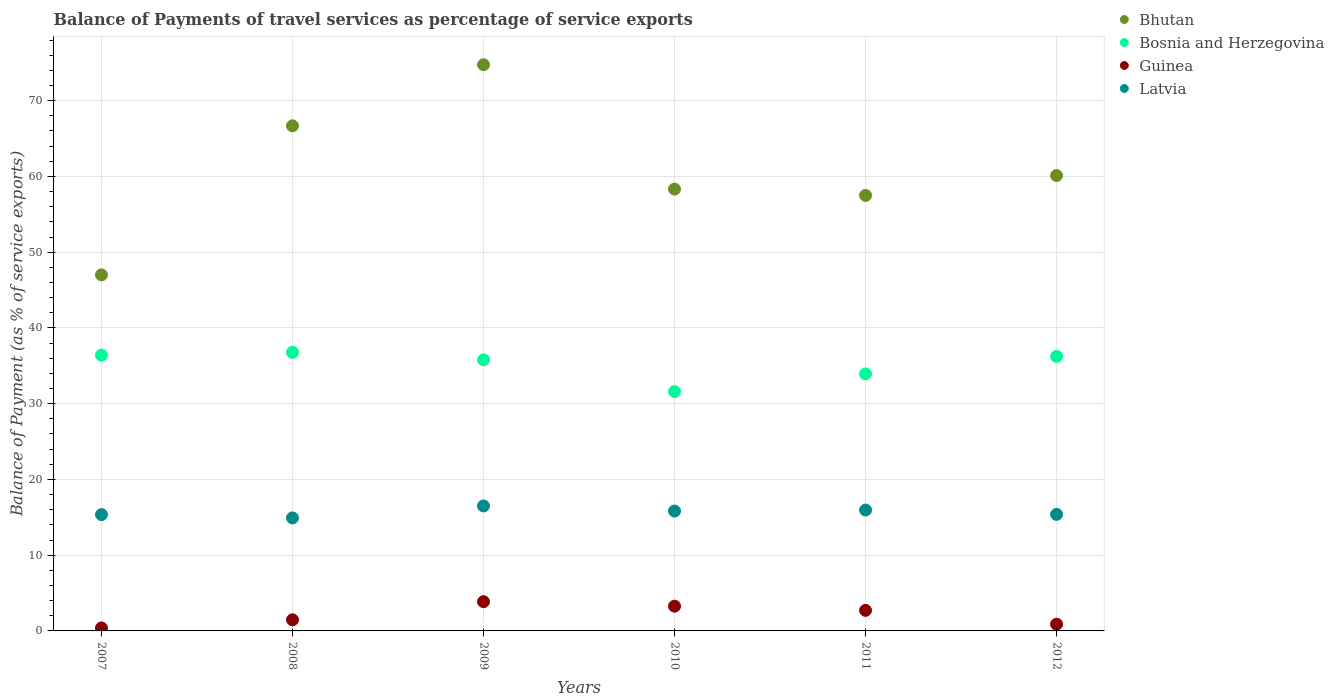What is the balance of payments of travel services in Bosnia and Herzegovina in 2009?
Ensure brevity in your answer.  35.79. Across all years, what is the maximum balance of payments of travel services in Bhutan?
Offer a very short reply. 74.75. Across all years, what is the minimum balance of payments of travel services in Latvia?
Give a very brief answer. 14.92. In which year was the balance of payments of travel services in Guinea minimum?
Your answer should be compact. 2007. What is the total balance of payments of travel services in Bhutan in the graph?
Keep it short and to the point. 364.38. What is the difference between the balance of payments of travel services in Latvia in 2007 and that in 2012?
Ensure brevity in your answer.  -0.04. What is the difference between the balance of payments of travel services in Bhutan in 2011 and the balance of payments of travel services in Guinea in 2012?
Offer a very short reply. 56.61. What is the average balance of payments of travel services in Latvia per year?
Provide a succinct answer. 15.66. In the year 2012, what is the difference between the balance of payments of travel services in Guinea and balance of payments of travel services in Latvia?
Provide a short and direct response. -14.5. In how many years, is the balance of payments of travel services in Bhutan greater than 16 %?
Your response must be concise. 6. What is the ratio of the balance of payments of travel services in Bosnia and Herzegovina in 2007 to that in 2008?
Your response must be concise. 0.99. Is the balance of payments of travel services in Guinea in 2008 less than that in 2011?
Offer a very short reply. Yes. What is the difference between the highest and the second highest balance of payments of travel services in Bhutan?
Your response must be concise. 8.06. What is the difference between the highest and the lowest balance of payments of travel services in Guinea?
Offer a terse response. 3.47. In how many years, is the balance of payments of travel services in Bosnia and Herzegovina greater than the average balance of payments of travel services in Bosnia and Herzegovina taken over all years?
Your answer should be very brief. 4. Is the sum of the balance of payments of travel services in Bhutan in 2007 and 2009 greater than the maximum balance of payments of travel services in Guinea across all years?
Keep it short and to the point. Yes. Is it the case that in every year, the sum of the balance of payments of travel services in Guinea and balance of payments of travel services in Bosnia and Herzegovina  is greater than the sum of balance of payments of travel services in Bhutan and balance of payments of travel services in Latvia?
Make the answer very short. Yes. Does the balance of payments of travel services in Latvia monotonically increase over the years?
Keep it short and to the point. No. Is the balance of payments of travel services in Bosnia and Herzegovina strictly greater than the balance of payments of travel services in Latvia over the years?
Provide a short and direct response. Yes. Is the balance of payments of travel services in Bosnia and Herzegovina strictly less than the balance of payments of travel services in Bhutan over the years?
Offer a terse response. Yes. How many dotlines are there?
Make the answer very short. 4. How many years are there in the graph?
Your answer should be very brief. 6. Does the graph contain grids?
Offer a very short reply. Yes. How many legend labels are there?
Offer a very short reply. 4. What is the title of the graph?
Provide a succinct answer. Balance of Payments of travel services as percentage of service exports. Does "Ukraine" appear as one of the legend labels in the graph?
Offer a very short reply. No. What is the label or title of the Y-axis?
Ensure brevity in your answer.  Balance of Payment (as % of service exports). What is the Balance of Payment (as % of service exports) of Bhutan in 2007?
Ensure brevity in your answer.  47. What is the Balance of Payment (as % of service exports) of Bosnia and Herzegovina in 2007?
Your answer should be very brief. 36.41. What is the Balance of Payment (as % of service exports) in Guinea in 2007?
Your response must be concise. 0.39. What is the Balance of Payment (as % of service exports) in Latvia in 2007?
Offer a terse response. 15.35. What is the Balance of Payment (as % of service exports) of Bhutan in 2008?
Provide a short and direct response. 66.68. What is the Balance of Payment (as % of service exports) of Bosnia and Herzegovina in 2008?
Give a very brief answer. 36.78. What is the Balance of Payment (as % of service exports) in Guinea in 2008?
Provide a short and direct response. 1.47. What is the Balance of Payment (as % of service exports) of Latvia in 2008?
Keep it short and to the point. 14.92. What is the Balance of Payment (as % of service exports) of Bhutan in 2009?
Offer a very short reply. 74.75. What is the Balance of Payment (as % of service exports) of Bosnia and Herzegovina in 2009?
Your response must be concise. 35.79. What is the Balance of Payment (as % of service exports) of Guinea in 2009?
Offer a very short reply. 3.86. What is the Balance of Payment (as % of service exports) in Latvia in 2009?
Ensure brevity in your answer.  16.5. What is the Balance of Payment (as % of service exports) in Bhutan in 2010?
Keep it short and to the point. 58.33. What is the Balance of Payment (as % of service exports) of Bosnia and Herzegovina in 2010?
Your answer should be very brief. 31.59. What is the Balance of Payment (as % of service exports) in Guinea in 2010?
Your response must be concise. 3.27. What is the Balance of Payment (as % of service exports) of Latvia in 2010?
Offer a terse response. 15.83. What is the Balance of Payment (as % of service exports) in Bhutan in 2011?
Give a very brief answer. 57.5. What is the Balance of Payment (as % of service exports) in Bosnia and Herzegovina in 2011?
Make the answer very short. 33.93. What is the Balance of Payment (as % of service exports) in Guinea in 2011?
Ensure brevity in your answer.  2.71. What is the Balance of Payment (as % of service exports) in Latvia in 2011?
Keep it short and to the point. 15.96. What is the Balance of Payment (as % of service exports) of Bhutan in 2012?
Your response must be concise. 60.12. What is the Balance of Payment (as % of service exports) in Bosnia and Herzegovina in 2012?
Provide a short and direct response. 36.25. What is the Balance of Payment (as % of service exports) in Guinea in 2012?
Give a very brief answer. 0.89. What is the Balance of Payment (as % of service exports) in Latvia in 2012?
Offer a very short reply. 15.39. Across all years, what is the maximum Balance of Payment (as % of service exports) in Bhutan?
Keep it short and to the point. 74.75. Across all years, what is the maximum Balance of Payment (as % of service exports) in Bosnia and Herzegovina?
Keep it short and to the point. 36.78. Across all years, what is the maximum Balance of Payment (as % of service exports) in Guinea?
Provide a short and direct response. 3.86. Across all years, what is the maximum Balance of Payment (as % of service exports) of Latvia?
Provide a short and direct response. 16.5. Across all years, what is the minimum Balance of Payment (as % of service exports) in Bhutan?
Give a very brief answer. 47. Across all years, what is the minimum Balance of Payment (as % of service exports) in Bosnia and Herzegovina?
Your response must be concise. 31.59. Across all years, what is the minimum Balance of Payment (as % of service exports) of Guinea?
Provide a succinct answer. 0.39. Across all years, what is the minimum Balance of Payment (as % of service exports) of Latvia?
Ensure brevity in your answer.  14.92. What is the total Balance of Payment (as % of service exports) of Bhutan in the graph?
Offer a very short reply. 364.38. What is the total Balance of Payment (as % of service exports) of Bosnia and Herzegovina in the graph?
Your answer should be compact. 210.75. What is the total Balance of Payment (as % of service exports) in Guinea in the graph?
Make the answer very short. 12.59. What is the total Balance of Payment (as % of service exports) in Latvia in the graph?
Provide a succinct answer. 93.94. What is the difference between the Balance of Payment (as % of service exports) in Bhutan in 2007 and that in 2008?
Provide a short and direct response. -19.68. What is the difference between the Balance of Payment (as % of service exports) in Bosnia and Herzegovina in 2007 and that in 2008?
Keep it short and to the point. -0.38. What is the difference between the Balance of Payment (as % of service exports) of Guinea in 2007 and that in 2008?
Ensure brevity in your answer.  -1.08. What is the difference between the Balance of Payment (as % of service exports) of Latvia in 2007 and that in 2008?
Ensure brevity in your answer.  0.43. What is the difference between the Balance of Payment (as % of service exports) of Bhutan in 2007 and that in 2009?
Provide a succinct answer. -27.74. What is the difference between the Balance of Payment (as % of service exports) of Bosnia and Herzegovina in 2007 and that in 2009?
Offer a terse response. 0.62. What is the difference between the Balance of Payment (as % of service exports) of Guinea in 2007 and that in 2009?
Give a very brief answer. -3.47. What is the difference between the Balance of Payment (as % of service exports) of Latvia in 2007 and that in 2009?
Make the answer very short. -1.15. What is the difference between the Balance of Payment (as % of service exports) in Bhutan in 2007 and that in 2010?
Keep it short and to the point. -11.33. What is the difference between the Balance of Payment (as % of service exports) in Bosnia and Herzegovina in 2007 and that in 2010?
Ensure brevity in your answer.  4.81. What is the difference between the Balance of Payment (as % of service exports) of Guinea in 2007 and that in 2010?
Keep it short and to the point. -2.88. What is the difference between the Balance of Payment (as % of service exports) in Latvia in 2007 and that in 2010?
Keep it short and to the point. -0.48. What is the difference between the Balance of Payment (as % of service exports) in Bhutan in 2007 and that in 2011?
Provide a short and direct response. -10.49. What is the difference between the Balance of Payment (as % of service exports) of Bosnia and Herzegovina in 2007 and that in 2011?
Provide a succinct answer. 2.47. What is the difference between the Balance of Payment (as % of service exports) of Guinea in 2007 and that in 2011?
Offer a very short reply. -2.32. What is the difference between the Balance of Payment (as % of service exports) in Latvia in 2007 and that in 2011?
Provide a short and direct response. -0.61. What is the difference between the Balance of Payment (as % of service exports) of Bhutan in 2007 and that in 2012?
Provide a succinct answer. -13.12. What is the difference between the Balance of Payment (as % of service exports) in Bosnia and Herzegovina in 2007 and that in 2012?
Offer a very short reply. 0.16. What is the difference between the Balance of Payment (as % of service exports) in Guinea in 2007 and that in 2012?
Your answer should be very brief. -0.5. What is the difference between the Balance of Payment (as % of service exports) in Latvia in 2007 and that in 2012?
Offer a terse response. -0.04. What is the difference between the Balance of Payment (as % of service exports) in Bhutan in 2008 and that in 2009?
Make the answer very short. -8.06. What is the difference between the Balance of Payment (as % of service exports) of Guinea in 2008 and that in 2009?
Provide a succinct answer. -2.39. What is the difference between the Balance of Payment (as % of service exports) of Latvia in 2008 and that in 2009?
Ensure brevity in your answer.  -1.58. What is the difference between the Balance of Payment (as % of service exports) of Bhutan in 2008 and that in 2010?
Provide a short and direct response. 8.36. What is the difference between the Balance of Payment (as % of service exports) in Bosnia and Herzegovina in 2008 and that in 2010?
Provide a succinct answer. 5.19. What is the difference between the Balance of Payment (as % of service exports) in Guinea in 2008 and that in 2010?
Offer a very short reply. -1.8. What is the difference between the Balance of Payment (as % of service exports) in Latvia in 2008 and that in 2010?
Offer a terse response. -0.91. What is the difference between the Balance of Payment (as % of service exports) of Bhutan in 2008 and that in 2011?
Your answer should be compact. 9.19. What is the difference between the Balance of Payment (as % of service exports) of Bosnia and Herzegovina in 2008 and that in 2011?
Your response must be concise. 2.85. What is the difference between the Balance of Payment (as % of service exports) in Guinea in 2008 and that in 2011?
Give a very brief answer. -1.25. What is the difference between the Balance of Payment (as % of service exports) of Latvia in 2008 and that in 2011?
Keep it short and to the point. -1.04. What is the difference between the Balance of Payment (as % of service exports) of Bhutan in 2008 and that in 2012?
Provide a succinct answer. 6.56. What is the difference between the Balance of Payment (as % of service exports) in Bosnia and Herzegovina in 2008 and that in 2012?
Make the answer very short. 0.54. What is the difference between the Balance of Payment (as % of service exports) of Guinea in 2008 and that in 2012?
Your answer should be compact. 0.58. What is the difference between the Balance of Payment (as % of service exports) in Latvia in 2008 and that in 2012?
Your answer should be compact. -0.47. What is the difference between the Balance of Payment (as % of service exports) of Bhutan in 2009 and that in 2010?
Ensure brevity in your answer.  16.42. What is the difference between the Balance of Payment (as % of service exports) in Bosnia and Herzegovina in 2009 and that in 2010?
Give a very brief answer. 4.2. What is the difference between the Balance of Payment (as % of service exports) in Guinea in 2009 and that in 2010?
Make the answer very short. 0.59. What is the difference between the Balance of Payment (as % of service exports) of Latvia in 2009 and that in 2010?
Offer a very short reply. 0.67. What is the difference between the Balance of Payment (as % of service exports) of Bhutan in 2009 and that in 2011?
Your answer should be compact. 17.25. What is the difference between the Balance of Payment (as % of service exports) in Bosnia and Herzegovina in 2009 and that in 2011?
Keep it short and to the point. 1.86. What is the difference between the Balance of Payment (as % of service exports) of Guinea in 2009 and that in 2011?
Ensure brevity in your answer.  1.15. What is the difference between the Balance of Payment (as % of service exports) of Latvia in 2009 and that in 2011?
Keep it short and to the point. 0.54. What is the difference between the Balance of Payment (as % of service exports) of Bhutan in 2009 and that in 2012?
Your response must be concise. 14.63. What is the difference between the Balance of Payment (as % of service exports) of Bosnia and Herzegovina in 2009 and that in 2012?
Your response must be concise. -0.46. What is the difference between the Balance of Payment (as % of service exports) of Guinea in 2009 and that in 2012?
Keep it short and to the point. 2.98. What is the difference between the Balance of Payment (as % of service exports) of Latvia in 2009 and that in 2012?
Ensure brevity in your answer.  1.11. What is the difference between the Balance of Payment (as % of service exports) of Bhutan in 2010 and that in 2011?
Offer a very short reply. 0.83. What is the difference between the Balance of Payment (as % of service exports) in Bosnia and Herzegovina in 2010 and that in 2011?
Offer a terse response. -2.34. What is the difference between the Balance of Payment (as % of service exports) in Guinea in 2010 and that in 2011?
Provide a short and direct response. 0.55. What is the difference between the Balance of Payment (as % of service exports) of Latvia in 2010 and that in 2011?
Keep it short and to the point. -0.13. What is the difference between the Balance of Payment (as % of service exports) in Bhutan in 2010 and that in 2012?
Your answer should be compact. -1.79. What is the difference between the Balance of Payment (as % of service exports) of Bosnia and Herzegovina in 2010 and that in 2012?
Your response must be concise. -4.66. What is the difference between the Balance of Payment (as % of service exports) of Guinea in 2010 and that in 2012?
Provide a short and direct response. 2.38. What is the difference between the Balance of Payment (as % of service exports) in Latvia in 2010 and that in 2012?
Keep it short and to the point. 0.44. What is the difference between the Balance of Payment (as % of service exports) of Bhutan in 2011 and that in 2012?
Give a very brief answer. -2.62. What is the difference between the Balance of Payment (as % of service exports) in Bosnia and Herzegovina in 2011 and that in 2012?
Provide a short and direct response. -2.32. What is the difference between the Balance of Payment (as % of service exports) in Guinea in 2011 and that in 2012?
Ensure brevity in your answer.  1.83. What is the difference between the Balance of Payment (as % of service exports) in Latvia in 2011 and that in 2012?
Make the answer very short. 0.57. What is the difference between the Balance of Payment (as % of service exports) in Bhutan in 2007 and the Balance of Payment (as % of service exports) in Bosnia and Herzegovina in 2008?
Make the answer very short. 10.22. What is the difference between the Balance of Payment (as % of service exports) in Bhutan in 2007 and the Balance of Payment (as % of service exports) in Guinea in 2008?
Your answer should be very brief. 45.53. What is the difference between the Balance of Payment (as % of service exports) of Bhutan in 2007 and the Balance of Payment (as % of service exports) of Latvia in 2008?
Keep it short and to the point. 32.08. What is the difference between the Balance of Payment (as % of service exports) of Bosnia and Herzegovina in 2007 and the Balance of Payment (as % of service exports) of Guinea in 2008?
Make the answer very short. 34.94. What is the difference between the Balance of Payment (as % of service exports) of Bosnia and Herzegovina in 2007 and the Balance of Payment (as % of service exports) of Latvia in 2008?
Make the answer very short. 21.48. What is the difference between the Balance of Payment (as % of service exports) in Guinea in 2007 and the Balance of Payment (as % of service exports) in Latvia in 2008?
Ensure brevity in your answer.  -14.53. What is the difference between the Balance of Payment (as % of service exports) of Bhutan in 2007 and the Balance of Payment (as % of service exports) of Bosnia and Herzegovina in 2009?
Make the answer very short. 11.21. What is the difference between the Balance of Payment (as % of service exports) in Bhutan in 2007 and the Balance of Payment (as % of service exports) in Guinea in 2009?
Your response must be concise. 43.14. What is the difference between the Balance of Payment (as % of service exports) in Bhutan in 2007 and the Balance of Payment (as % of service exports) in Latvia in 2009?
Your answer should be very brief. 30.5. What is the difference between the Balance of Payment (as % of service exports) of Bosnia and Herzegovina in 2007 and the Balance of Payment (as % of service exports) of Guinea in 2009?
Provide a succinct answer. 32.54. What is the difference between the Balance of Payment (as % of service exports) of Bosnia and Herzegovina in 2007 and the Balance of Payment (as % of service exports) of Latvia in 2009?
Keep it short and to the point. 19.91. What is the difference between the Balance of Payment (as % of service exports) of Guinea in 2007 and the Balance of Payment (as % of service exports) of Latvia in 2009?
Provide a succinct answer. -16.11. What is the difference between the Balance of Payment (as % of service exports) of Bhutan in 2007 and the Balance of Payment (as % of service exports) of Bosnia and Herzegovina in 2010?
Your response must be concise. 15.41. What is the difference between the Balance of Payment (as % of service exports) in Bhutan in 2007 and the Balance of Payment (as % of service exports) in Guinea in 2010?
Your answer should be compact. 43.73. What is the difference between the Balance of Payment (as % of service exports) of Bhutan in 2007 and the Balance of Payment (as % of service exports) of Latvia in 2010?
Your answer should be compact. 31.17. What is the difference between the Balance of Payment (as % of service exports) of Bosnia and Herzegovina in 2007 and the Balance of Payment (as % of service exports) of Guinea in 2010?
Provide a succinct answer. 33.14. What is the difference between the Balance of Payment (as % of service exports) in Bosnia and Herzegovina in 2007 and the Balance of Payment (as % of service exports) in Latvia in 2010?
Make the answer very short. 20.58. What is the difference between the Balance of Payment (as % of service exports) of Guinea in 2007 and the Balance of Payment (as % of service exports) of Latvia in 2010?
Your response must be concise. -15.44. What is the difference between the Balance of Payment (as % of service exports) in Bhutan in 2007 and the Balance of Payment (as % of service exports) in Bosnia and Herzegovina in 2011?
Provide a short and direct response. 13.07. What is the difference between the Balance of Payment (as % of service exports) in Bhutan in 2007 and the Balance of Payment (as % of service exports) in Guinea in 2011?
Provide a succinct answer. 44.29. What is the difference between the Balance of Payment (as % of service exports) of Bhutan in 2007 and the Balance of Payment (as % of service exports) of Latvia in 2011?
Your response must be concise. 31.04. What is the difference between the Balance of Payment (as % of service exports) of Bosnia and Herzegovina in 2007 and the Balance of Payment (as % of service exports) of Guinea in 2011?
Your response must be concise. 33.69. What is the difference between the Balance of Payment (as % of service exports) of Bosnia and Herzegovina in 2007 and the Balance of Payment (as % of service exports) of Latvia in 2011?
Ensure brevity in your answer.  20.45. What is the difference between the Balance of Payment (as % of service exports) of Guinea in 2007 and the Balance of Payment (as % of service exports) of Latvia in 2011?
Provide a short and direct response. -15.57. What is the difference between the Balance of Payment (as % of service exports) in Bhutan in 2007 and the Balance of Payment (as % of service exports) in Bosnia and Herzegovina in 2012?
Provide a short and direct response. 10.75. What is the difference between the Balance of Payment (as % of service exports) of Bhutan in 2007 and the Balance of Payment (as % of service exports) of Guinea in 2012?
Offer a terse response. 46.12. What is the difference between the Balance of Payment (as % of service exports) in Bhutan in 2007 and the Balance of Payment (as % of service exports) in Latvia in 2012?
Offer a very short reply. 31.61. What is the difference between the Balance of Payment (as % of service exports) of Bosnia and Herzegovina in 2007 and the Balance of Payment (as % of service exports) of Guinea in 2012?
Offer a very short reply. 35.52. What is the difference between the Balance of Payment (as % of service exports) in Bosnia and Herzegovina in 2007 and the Balance of Payment (as % of service exports) in Latvia in 2012?
Give a very brief answer. 21.02. What is the difference between the Balance of Payment (as % of service exports) in Guinea in 2007 and the Balance of Payment (as % of service exports) in Latvia in 2012?
Make the answer very short. -15. What is the difference between the Balance of Payment (as % of service exports) of Bhutan in 2008 and the Balance of Payment (as % of service exports) of Bosnia and Herzegovina in 2009?
Offer a very short reply. 30.9. What is the difference between the Balance of Payment (as % of service exports) of Bhutan in 2008 and the Balance of Payment (as % of service exports) of Guinea in 2009?
Provide a succinct answer. 62.82. What is the difference between the Balance of Payment (as % of service exports) of Bhutan in 2008 and the Balance of Payment (as % of service exports) of Latvia in 2009?
Provide a short and direct response. 50.19. What is the difference between the Balance of Payment (as % of service exports) in Bosnia and Herzegovina in 2008 and the Balance of Payment (as % of service exports) in Guinea in 2009?
Your answer should be compact. 32.92. What is the difference between the Balance of Payment (as % of service exports) in Bosnia and Herzegovina in 2008 and the Balance of Payment (as % of service exports) in Latvia in 2009?
Your response must be concise. 20.29. What is the difference between the Balance of Payment (as % of service exports) in Guinea in 2008 and the Balance of Payment (as % of service exports) in Latvia in 2009?
Keep it short and to the point. -15.03. What is the difference between the Balance of Payment (as % of service exports) of Bhutan in 2008 and the Balance of Payment (as % of service exports) of Bosnia and Herzegovina in 2010?
Ensure brevity in your answer.  35.09. What is the difference between the Balance of Payment (as % of service exports) of Bhutan in 2008 and the Balance of Payment (as % of service exports) of Guinea in 2010?
Give a very brief answer. 63.42. What is the difference between the Balance of Payment (as % of service exports) in Bhutan in 2008 and the Balance of Payment (as % of service exports) in Latvia in 2010?
Keep it short and to the point. 50.86. What is the difference between the Balance of Payment (as % of service exports) of Bosnia and Herzegovina in 2008 and the Balance of Payment (as % of service exports) of Guinea in 2010?
Provide a succinct answer. 33.52. What is the difference between the Balance of Payment (as % of service exports) of Bosnia and Herzegovina in 2008 and the Balance of Payment (as % of service exports) of Latvia in 2010?
Ensure brevity in your answer.  20.96. What is the difference between the Balance of Payment (as % of service exports) in Guinea in 2008 and the Balance of Payment (as % of service exports) in Latvia in 2010?
Your response must be concise. -14.36. What is the difference between the Balance of Payment (as % of service exports) of Bhutan in 2008 and the Balance of Payment (as % of service exports) of Bosnia and Herzegovina in 2011?
Your response must be concise. 32.75. What is the difference between the Balance of Payment (as % of service exports) of Bhutan in 2008 and the Balance of Payment (as % of service exports) of Guinea in 2011?
Offer a terse response. 63.97. What is the difference between the Balance of Payment (as % of service exports) in Bhutan in 2008 and the Balance of Payment (as % of service exports) in Latvia in 2011?
Make the answer very short. 50.73. What is the difference between the Balance of Payment (as % of service exports) of Bosnia and Herzegovina in 2008 and the Balance of Payment (as % of service exports) of Guinea in 2011?
Give a very brief answer. 34.07. What is the difference between the Balance of Payment (as % of service exports) in Bosnia and Herzegovina in 2008 and the Balance of Payment (as % of service exports) in Latvia in 2011?
Offer a very short reply. 20.83. What is the difference between the Balance of Payment (as % of service exports) of Guinea in 2008 and the Balance of Payment (as % of service exports) of Latvia in 2011?
Ensure brevity in your answer.  -14.49. What is the difference between the Balance of Payment (as % of service exports) of Bhutan in 2008 and the Balance of Payment (as % of service exports) of Bosnia and Herzegovina in 2012?
Keep it short and to the point. 30.44. What is the difference between the Balance of Payment (as % of service exports) in Bhutan in 2008 and the Balance of Payment (as % of service exports) in Guinea in 2012?
Your answer should be compact. 65.8. What is the difference between the Balance of Payment (as % of service exports) of Bhutan in 2008 and the Balance of Payment (as % of service exports) of Latvia in 2012?
Offer a terse response. 51.3. What is the difference between the Balance of Payment (as % of service exports) in Bosnia and Herzegovina in 2008 and the Balance of Payment (as % of service exports) in Guinea in 2012?
Make the answer very short. 35.9. What is the difference between the Balance of Payment (as % of service exports) of Bosnia and Herzegovina in 2008 and the Balance of Payment (as % of service exports) of Latvia in 2012?
Your response must be concise. 21.4. What is the difference between the Balance of Payment (as % of service exports) of Guinea in 2008 and the Balance of Payment (as % of service exports) of Latvia in 2012?
Offer a terse response. -13.92. What is the difference between the Balance of Payment (as % of service exports) of Bhutan in 2009 and the Balance of Payment (as % of service exports) of Bosnia and Herzegovina in 2010?
Offer a very short reply. 43.15. What is the difference between the Balance of Payment (as % of service exports) of Bhutan in 2009 and the Balance of Payment (as % of service exports) of Guinea in 2010?
Offer a terse response. 71.48. What is the difference between the Balance of Payment (as % of service exports) in Bhutan in 2009 and the Balance of Payment (as % of service exports) in Latvia in 2010?
Your answer should be compact. 58.92. What is the difference between the Balance of Payment (as % of service exports) in Bosnia and Herzegovina in 2009 and the Balance of Payment (as % of service exports) in Guinea in 2010?
Offer a terse response. 32.52. What is the difference between the Balance of Payment (as % of service exports) of Bosnia and Herzegovina in 2009 and the Balance of Payment (as % of service exports) of Latvia in 2010?
Offer a terse response. 19.96. What is the difference between the Balance of Payment (as % of service exports) in Guinea in 2009 and the Balance of Payment (as % of service exports) in Latvia in 2010?
Offer a very short reply. -11.96. What is the difference between the Balance of Payment (as % of service exports) in Bhutan in 2009 and the Balance of Payment (as % of service exports) in Bosnia and Herzegovina in 2011?
Offer a terse response. 40.81. What is the difference between the Balance of Payment (as % of service exports) of Bhutan in 2009 and the Balance of Payment (as % of service exports) of Guinea in 2011?
Make the answer very short. 72.03. What is the difference between the Balance of Payment (as % of service exports) in Bhutan in 2009 and the Balance of Payment (as % of service exports) in Latvia in 2011?
Provide a succinct answer. 58.79. What is the difference between the Balance of Payment (as % of service exports) of Bosnia and Herzegovina in 2009 and the Balance of Payment (as % of service exports) of Guinea in 2011?
Your response must be concise. 33.07. What is the difference between the Balance of Payment (as % of service exports) in Bosnia and Herzegovina in 2009 and the Balance of Payment (as % of service exports) in Latvia in 2011?
Keep it short and to the point. 19.83. What is the difference between the Balance of Payment (as % of service exports) in Guinea in 2009 and the Balance of Payment (as % of service exports) in Latvia in 2011?
Your answer should be compact. -12.1. What is the difference between the Balance of Payment (as % of service exports) of Bhutan in 2009 and the Balance of Payment (as % of service exports) of Bosnia and Herzegovina in 2012?
Offer a terse response. 38.5. What is the difference between the Balance of Payment (as % of service exports) in Bhutan in 2009 and the Balance of Payment (as % of service exports) in Guinea in 2012?
Your response must be concise. 73.86. What is the difference between the Balance of Payment (as % of service exports) of Bhutan in 2009 and the Balance of Payment (as % of service exports) of Latvia in 2012?
Your answer should be very brief. 59.36. What is the difference between the Balance of Payment (as % of service exports) of Bosnia and Herzegovina in 2009 and the Balance of Payment (as % of service exports) of Guinea in 2012?
Ensure brevity in your answer.  34.9. What is the difference between the Balance of Payment (as % of service exports) of Bosnia and Herzegovina in 2009 and the Balance of Payment (as % of service exports) of Latvia in 2012?
Your answer should be very brief. 20.4. What is the difference between the Balance of Payment (as % of service exports) of Guinea in 2009 and the Balance of Payment (as % of service exports) of Latvia in 2012?
Provide a short and direct response. -11.53. What is the difference between the Balance of Payment (as % of service exports) in Bhutan in 2010 and the Balance of Payment (as % of service exports) in Bosnia and Herzegovina in 2011?
Give a very brief answer. 24.4. What is the difference between the Balance of Payment (as % of service exports) in Bhutan in 2010 and the Balance of Payment (as % of service exports) in Guinea in 2011?
Provide a short and direct response. 55.61. What is the difference between the Balance of Payment (as % of service exports) in Bhutan in 2010 and the Balance of Payment (as % of service exports) in Latvia in 2011?
Provide a short and direct response. 42.37. What is the difference between the Balance of Payment (as % of service exports) of Bosnia and Herzegovina in 2010 and the Balance of Payment (as % of service exports) of Guinea in 2011?
Your answer should be very brief. 28.88. What is the difference between the Balance of Payment (as % of service exports) of Bosnia and Herzegovina in 2010 and the Balance of Payment (as % of service exports) of Latvia in 2011?
Offer a terse response. 15.63. What is the difference between the Balance of Payment (as % of service exports) of Guinea in 2010 and the Balance of Payment (as % of service exports) of Latvia in 2011?
Provide a succinct answer. -12.69. What is the difference between the Balance of Payment (as % of service exports) of Bhutan in 2010 and the Balance of Payment (as % of service exports) of Bosnia and Herzegovina in 2012?
Give a very brief answer. 22.08. What is the difference between the Balance of Payment (as % of service exports) in Bhutan in 2010 and the Balance of Payment (as % of service exports) in Guinea in 2012?
Make the answer very short. 57.44. What is the difference between the Balance of Payment (as % of service exports) in Bhutan in 2010 and the Balance of Payment (as % of service exports) in Latvia in 2012?
Give a very brief answer. 42.94. What is the difference between the Balance of Payment (as % of service exports) of Bosnia and Herzegovina in 2010 and the Balance of Payment (as % of service exports) of Guinea in 2012?
Offer a terse response. 30.71. What is the difference between the Balance of Payment (as % of service exports) in Bosnia and Herzegovina in 2010 and the Balance of Payment (as % of service exports) in Latvia in 2012?
Your response must be concise. 16.2. What is the difference between the Balance of Payment (as % of service exports) of Guinea in 2010 and the Balance of Payment (as % of service exports) of Latvia in 2012?
Offer a terse response. -12.12. What is the difference between the Balance of Payment (as % of service exports) of Bhutan in 2011 and the Balance of Payment (as % of service exports) of Bosnia and Herzegovina in 2012?
Make the answer very short. 21.25. What is the difference between the Balance of Payment (as % of service exports) in Bhutan in 2011 and the Balance of Payment (as % of service exports) in Guinea in 2012?
Offer a very short reply. 56.61. What is the difference between the Balance of Payment (as % of service exports) of Bhutan in 2011 and the Balance of Payment (as % of service exports) of Latvia in 2012?
Your response must be concise. 42.11. What is the difference between the Balance of Payment (as % of service exports) of Bosnia and Herzegovina in 2011 and the Balance of Payment (as % of service exports) of Guinea in 2012?
Ensure brevity in your answer.  33.04. What is the difference between the Balance of Payment (as % of service exports) of Bosnia and Herzegovina in 2011 and the Balance of Payment (as % of service exports) of Latvia in 2012?
Keep it short and to the point. 18.54. What is the difference between the Balance of Payment (as % of service exports) in Guinea in 2011 and the Balance of Payment (as % of service exports) in Latvia in 2012?
Give a very brief answer. -12.67. What is the average Balance of Payment (as % of service exports) in Bhutan per year?
Provide a short and direct response. 60.73. What is the average Balance of Payment (as % of service exports) in Bosnia and Herzegovina per year?
Offer a terse response. 35.12. What is the average Balance of Payment (as % of service exports) in Guinea per year?
Make the answer very short. 2.1. What is the average Balance of Payment (as % of service exports) in Latvia per year?
Provide a short and direct response. 15.66. In the year 2007, what is the difference between the Balance of Payment (as % of service exports) in Bhutan and Balance of Payment (as % of service exports) in Bosnia and Herzegovina?
Provide a succinct answer. 10.6. In the year 2007, what is the difference between the Balance of Payment (as % of service exports) in Bhutan and Balance of Payment (as % of service exports) in Guinea?
Make the answer very short. 46.61. In the year 2007, what is the difference between the Balance of Payment (as % of service exports) in Bhutan and Balance of Payment (as % of service exports) in Latvia?
Keep it short and to the point. 31.65. In the year 2007, what is the difference between the Balance of Payment (as % of service exports) in Bosnia and Herzegovina and Balance of Payment (as % of service exports) in Guinea?
Your response must be concise. 36.02. In the year 2007, what is the difference between the Balance of Payment (as % of service exports) in Bosnia and Herzegovina and Balance of Payment (as % of service exports) in Latvia?
Provide a succinct answer. 21.05. In the year 2007, what is the difference between the Balance of Payment (as % of service exports) of Guinea and Balance of Payment (as % of service exports) of Latvia?
Provide a succinct answer. -14.96. In the year 2008, what is the difference between the Balance of Payment (as % of service exports) of Bhutan and Balance of Payment (as % of service exports) of Bosnia and Herzegovina?
Your answer should be compact. 29.9. In the year 2008, what is the difference between the Balance of Payment (as % of service exports) in Bhutan and Balance of Payment (as % of service exports) in Guinea?
Your response must be concise. 65.22. In the year 2008, what is the difference between the Balance of Payment (as % of service exports) of Bhutan and Balance of Payment (as % of service exports) of Latvia?
Offer a very short reply. 51.76. In the year 2008, what is the difference between the Balance of Payment (as % of service exports) in Bosnia and Herzegovina and Balance of Payment (as % of service exports) in Guinea?
Your answer should be very brief. 35.32. In the year 2008, what is the difference between the Balance of Payment (as % of service exports) of Bosnia and Herzegovina and Balance of Payment (as % of service exports) of Latvia?
Your answer should be very brief. 21.86. In the year 2008, what is the difference between the Balance of Payment (as % of service exports) of Guinea and Balance of Payment (as % of service exports) of Latvia?
Offer a terse response. -13.45. In the year 2009, what is the difference between the Balance of Payment (as % of service exports) of Bhutan and Balance of Payment (as % of service exports) of Bosnia and Herzegovina?
Give a very brief answer. 38.96. In the year 2009, what is the difference between the Balance of Payment (as % of service exports) in Bhutan and Balance of Payment (as % of service exports) in Guinea?
Give a very brief answer. 70.88. In the year 2009, what is the difference between the Balance of Payment (as % of service exports) in Bhutan and Balance of Payment (as % of service exports) in Latvia?
Provide a succinct answer. 58.25. In the year 2009, what is the difference between the Balance of Payment (as % of service exports) of Bosnia and Herzegovina and Balance of Payment (as % of service exports) of Guinea?
Your response must be concise. 31.93. In the year 2009, what is the difference between the Balance of Payment (as % of service exports) of Bosnia and Herzegovina and Balance of Payment (as % of service exports) of Latvia?
Your answer should be compact. 19.29. In the year 2009, what is the difference between the Balance of Payment (as % of service exports) of Guinea and Balance of Payment (as % of service exports) of Latvia?
Provide a succinct answer. -12.64. In the year 2010, what is the difference between the Balance of Payment (as % of service exports) in Bhutan and Balance of Payment (as % of service exports) in Bosnia and Herzegovina?
Your answer should be very brief. 26.74. In the year 2010, what is the difference between the Balance of Payment (as % of service exports) in Bhutan and Balance of Payment (as % of service exports) in Guinea?
Offer a very short reply. 55.06. In the year 2010, what is the difference between the Balance of Payment (as % of service exports) of Bhutan and Balance of Payment (as % of service exports) of Latvia?
Your answer should be very brief. 42.5. In the year 2010, what is the difference between the Balance of Payment (as % of service exports) in Bosnia and Herzegovina and Balance of Payment (as % of service exports) in Guinea?
Offer a very short reply. 28.32. In the year 2010, what is the difference between the Balance of Payment (as % of service exports) of Bosnia and Herzegovina and Balance of Payment (as % of service exports) of Latvia?
Offer a terse response. 15.77. In the year 2010, what is the difference between the Balance of Payment (as % of service exports) of Guinea and Balance of Payment (as % of service exports) of Latvia?
Keep it short and to the point. -12.56. In the year 2011, what is the difference between the Balance of Payment (as % of service exports) in Bhutan and Balance of Payment (as % of service exports) in Bosnia and Herzegovina?
Offer a very short reply. 23.57. In the year 2011, what is the difference between the Balance of Payment (as % of service exports) in Bhutan and Balance of Payment (as % of service exports) in Guinea?
Provide a short and direct response. 54.78. In the year 2011, what is the difference between the Balance of Payment (as % of service exports) of Bhutan and Balance of Payment (as % of service exports) of Latvia?
Make the answer very short. 41.54. In the year 2011, what is the difference between the Balance of Payment (as % of service exports) of Bosnia and Herzegovina and Balance of Payment (as % of service exports) of Guinea?
Offer a terse response. 31.22. In the year 2011, what is the difference between the Balance of Payment (as % of service exports) of Bosnia and Herzegovina and Balance of Payment (as % of service exports) of Latvia?
Make the answer very short. 17.97. In the year 2011, what is the difference between the Balance of Payment (as % of service exports) in Guinea and Balance of Payment (as % of service exports) in Latvia?
Offer a terse response. -13.24. In the year 2012, what is the difference between the Balance of Payment (as % of service exports) in Bhutan and Balance of Payment (as % of service exports) in Bosnia and Herzegovina?
Provide a short and direct response. 23.87. In the year 2012, what is the difference between the Balance of Payment (as % of service exports) in Bhutan and Balance of Payment (as % of service exports) in Guinea?
Ensure brevity in your answer.  59.23. In the year 2012, what is the difference between the Balance of Payment (as % of service exports) in Bhutan and Balance of Payment (as % of service exports) in Latvia?
Your response must be concise. 44.73. In the year 2012, what is the difference between the Balance of Payment (as % of service exports) of Bosnia and Herzegovina and Balance of Payment (as % of service exports) of Guinea?
Offer a very short reply. 35.36. In the year 2012, what is the difference between the Balance of Payment (as % of service exports) in Bosnia and Herzegovina and Balance of Payment (as % of service exports) in Latvia?
Provide a succinct answer. 20.86. In the year 2012, what is the difference between the Balance of Payment (as % of service exports) of Guinea and Balance of Payment (as % of service exports) of Latvia?
Provide a short and direct response. -14.5. What is the ratio of the Balance of Payment (as % of service exports) of Bhutan in 2007 to that in 2008?
Make the answer very short. 0.7. What is the ratio of the Balance of Payment (as % of service exports) of Bosnia and Herzegovina in 2007 to that in 2008?
Your answer should be very brief. 0.99. What is the ratio of the Balance of Payment (as % of service exports) of Guinea in 2007 to that in 2008?
Provide a short and direct response. 0.27. What is the ratio of the Balance of Payment (as % of service exports) of Latvia in 2007 to that in 2008?
Your answer should be very brief. 1.03. What is the ratio of the Balance of Payment (as % of service exports) in Bhutan in 2007 to that in 2009?
Offer a very short reply. 0.63. What is the ratio of the Balance of Payment (as % of service exports) of Bosnia and Herzegovina in 2007 to that in 2009?
Offer a terse response. 1.02. What is the ratio of the Balance of Payment (as % of service exports) in Guinea in 2007 to that in 2009?
Your response must be concise. 0.1. What is the ratio of the Balance of Payment (as % of service exports) of Latvia in 2007 to that in 2009?
Keep it short and to the point. 0.93. What is the ratio of the Balance of Payment (as % of service exports) in Bhutan in 2007 to that in 2010?
Make the answer very short. 0.81. What is the ratio of the Balance of Payment (as % of service exports) in Bosnia and Herzegovina in 2007 to that in 2010?
Offer a terse response. 1.15. What is the ratio of the Balance of Payment (as % of service exports) in Guinea in 2007 to that in 2010?
Provide a succinct answer. 0.12. What is the ratio of the Balance of Payment (as % of service exports) of Latvia in 2007 to that in 2010?
Offer a terse response. 0.97. What is the ratio of the Balance of Payment (as % of service exports) in Bhutan in 2007 to that in 2011?
Ensure brevity in your answer.  0.82. What is the ratio of the Balance of Payment (as % of service exports) of Bosnia and Herzegovina in 2007 to that in 2011?
Ensure brevity in your answer.  1.07. What is the ratio of the Balance of Payment (as % of service exports) of Guinea in 2007 to that in 2011?
Offer a terse response. 0.14. What is the ratio of the Balance of Payment (as % of service exports) of Latvia in 2007 to that in 2011?
Your answer should be very brief. 0.96. What is the ratio of the Balance of Payment (as % of service exports) of Bhutan in 2007 to that in 2012?
Offer a very short reply. 0.78. What is the ratio of the Balance of Payment (as % of service exports) of Bosnia and Herzegovina in 2007 to that in 2012?
Keep it short and to the point. 1. What is the ratio of the Balance of Payment (as % of service exports) of Guinea in 2007 to that in 2012?
Provide a succinct answer. 0.44. What is the ratio of the Balance of Payment (as % of service exports) in Bhutan in 2008 to that in 2009?
Provide a short and direct response. 0.89. What is the ratio of the Balance of Payment (as % of service exports) of Bosnia and Herzegovina in 2008 to that in 2009?
Offer a very short reply. 1.03. What is the ratio of the Balance of Payment (as % of service exports) of Guinea in 2008 to that in 2009?
Your answer should be very brief. 0.38. What is the ratio of the Balance of Payment (as % of service exports) in Latvia in 2008 to that in 2009?
Ensure brevity in your answer.  0.9. What is the ratio of the Balance of Payment (as % of service exports) in Bhutan in 2008 to that in 2010?
Your response must be concise. 1.14. What is the ratio of the Balance of Payment (as % of service exports) in Bosnia and Herzegovina in 2008 to that in 2010?
Your answer should be compact. 1.16. What is the ratio of the Balance of Payment (as % of service exports) in Guinea in 2008 to that in 2010?
Your response must be concise. 0.45. What is the ratio of the Balance of Payment (as % of service exports) in Latvia in 2008 to that in 2010?
Offer a very short reply. 0.94. What is the ratio of the Balance of Payment (as % of service exports) in Bhutan in 2008 to that in 2011?
Provide a short and direct response. 1.16. What is the ratio of the Balance of Payment (as % of service exports) of Bosnia and Herzegovina in 2008 to that in 2011?
Provide a short and direct response. 1.08. What is the ratio of the Balance of Payment (as % of service exports) of Guinea in 2008 to that in 2011?
Your answer should be compact. 0.54. What is the ratio of the Balance of Payment (as % of service exports) in Latvia in 2008 to that in 2011?
Ensure brevity in your answer.  0.93. What is the ratio of the Balance of Payment (as % of service exports) of Bhutan in 2008 to that in 2012?
Your response must be concise. 1.11. What is the ratio of the Balance of Payment (as % of service exports) in Bosnia and Herzegovina in 2008 to that in 2012?
Make the answer very short. 1.01. What is the ratio of the Balance of Payment (as % of service exports) of Guinea in 2008 to that in 2012?
Your response must be concise. 1.66. What is the ratio of the Balance of Payment (as % of service exports) in Latvia in 2008 to that in 2012?
Give a very brief answer. 0.97. What is the ratio of the Balance of Payment (as % of service exports) in Bhutan in 2009 to that in 2010?
Make the answer very short. 1.28. What is the ratio of the Balance of Payment (as % of service exports) in Bosnia and Herzegovina in 2009 to that in 2010?
Give a very brief answer. 1.13. What is the ratio of the Balance of Payment (as % of service exports) of Guinea in 2009 to that in 2010?
Your response must be concise. 1.18. What is the ratio of the Balance of Payment (as % of service exports) in Latvia in 2009 to that in 2010?
Offer a terse response. 1.04. What is the ratio of the Balance of Payment (as % of service exports) in Bosnia and Herzegovina in 2009 to that in 2011?
Offer a terse response. 1.05. What is the ratio of the Balance of Payment (as % of service exports) of Guinea in 2009 to that in 2011?
Your answer should be compact. 1.42. What is the ratio of the Balance of Payment (as % of service exports) of Latvia in 2009 to that in 2011?
Offer a very short reply. 1.03. What is the ratio of the Balance of Payment (as % of service exports) of Bhutan in 2009 to that in 2012?
Give a very brief answer. 1.24. What is the ratio of the Balance of Payment (as % of service exports) of Bosnia and Herzegovina in 2009 to that in 2012?
Offer a terse response. 0.99. What is the ratio of the Balance of Payment (as % of service exports) of Guinea in 2009 to that in 2012?
Ensure brevity in your answer.  4.36. What is the ratio of the Balance of Payment (as % of service exports) in Latvia in 2009 to that in 2012?
Offer a very short reply. 1.07. What is the ratio of the Balance of Payment (as % of service exports) in Bhutan in 2010 to that in 2011?
Make the answer very short. 1.01. What is the ratio of the Balance of Payment (as % of service exports) in Bosnia and Herzegovina in 2010 to that in 2011?
Give a very brief answer. 0.93. What is the ratio of the Balance of Payment (as % of service exports) of Guinea in 2010 to that in 2011?
Keep it short and to the point. 1.2. What is the ratio of the Balance of Payment (as % of service exports) of Bhutan in 2010 to that in 2012?
Offer a terse response. 0.97. What is the ratio of the Balance of Payment (as % of service exports) of Bosnia and Herzegovina in 2010 to that in 2012?
Keep it short and to the point. 0.87. What is the ratio of the Balance of Payment (as % of service exports) in Guinea in 2010 to that in 2012?
Your answer should be compact. 3.69. What is the ratio of the Balance of Payment (as % of service exports) of Latvia in 2010 to that in 2012?
Make the answer very short. 1.03. What is the ratio of the Balance of Payment (as % of service exports) of Bhutan in 2011 to that in 2012?
Offer a terse response. 0.96. What is the ratio of the Balance of Payment (as % of service exports) in Bosnia and Herzegovina in 2011 to that in 2012?
Your answer should be compact. 0.94. What is the ratio of the Balance of Payment (as % of service exports) in Guinea in 2011 to that in 2012?
Your answer should be very brief. 3.06. What is the ratio of the Balance of Payment (as % of service exports) in Latvia in 2011 to that in 2012?
Keep it short and to the point. 1.04. What is the difference between the highest and the second highest Balance of Payment (as % of service exports) in Bhutan?
Your answer should be very brief. 8.06. What is the difference between the highest and the second highest Balance of Payment (as % of service exports) in Bosnia and Herzegovina?
Offer a terse response. 0.38. What is the difference between the highest and the second highest Balance of Payment (as % of service exports) in Guinea?
Your answer should be very brief. 0.59. What is the difference between the highest and the second highest Balance of Payment (as % of service exports) of Latvia?
Ensure brevity in your answer.  0.54. What is the difference between the highest and the lowest Balance of Payment (as % of service exports) in Bhutan?
Make the answer very short. 27.74. What is the difference between the highest and the lowest Balance of Payment (as % of service exports) in Bosnia and Herzegovina?
Provide a short and direct response. 5.19. What is the difference between the highest and the lowest Balance of Payment (as % of service exports) in Guinea?
Keep it short and to the point. 3.47. What is the difference between the highest and the lowest Balance of Payment (as % of service exports) of Latvia?
Ensure brevity in your answer.  1.58. 